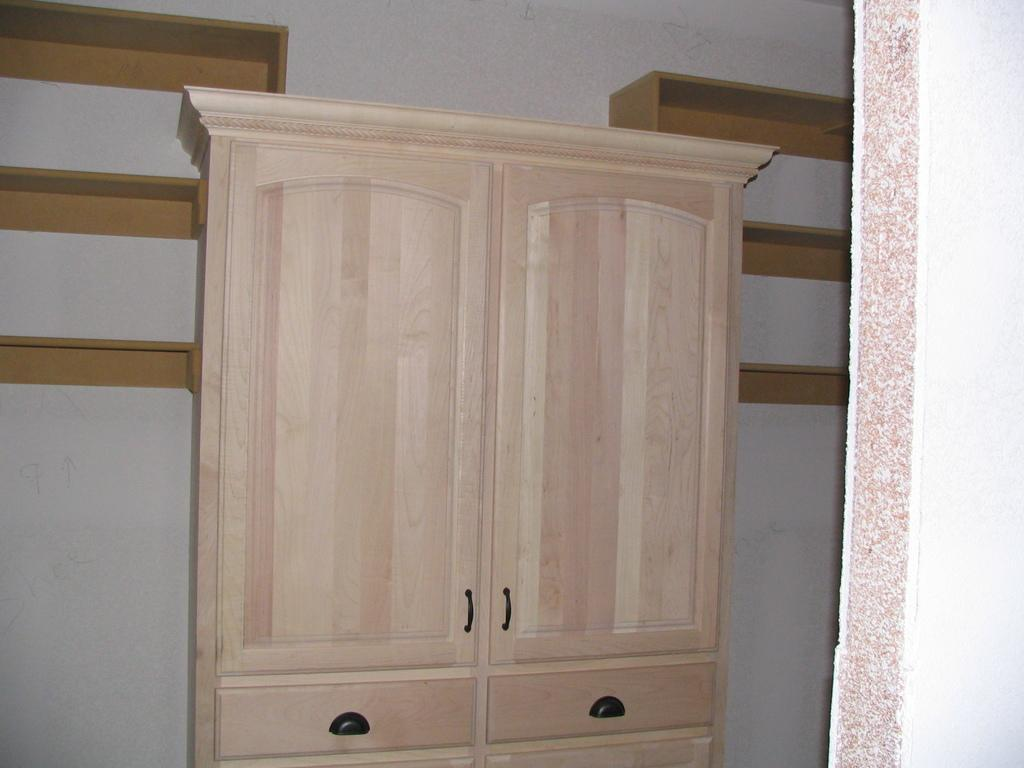What type of furniture is present in the image? There is a cupboard in the image. What can be seen in the background of the image? There is a wall and shelves in the background of the image. What type of brass instrument is being played by the company in the image? There is no brass instrument or company present in the image; it only features a cupboard, a wall, and shelves. 